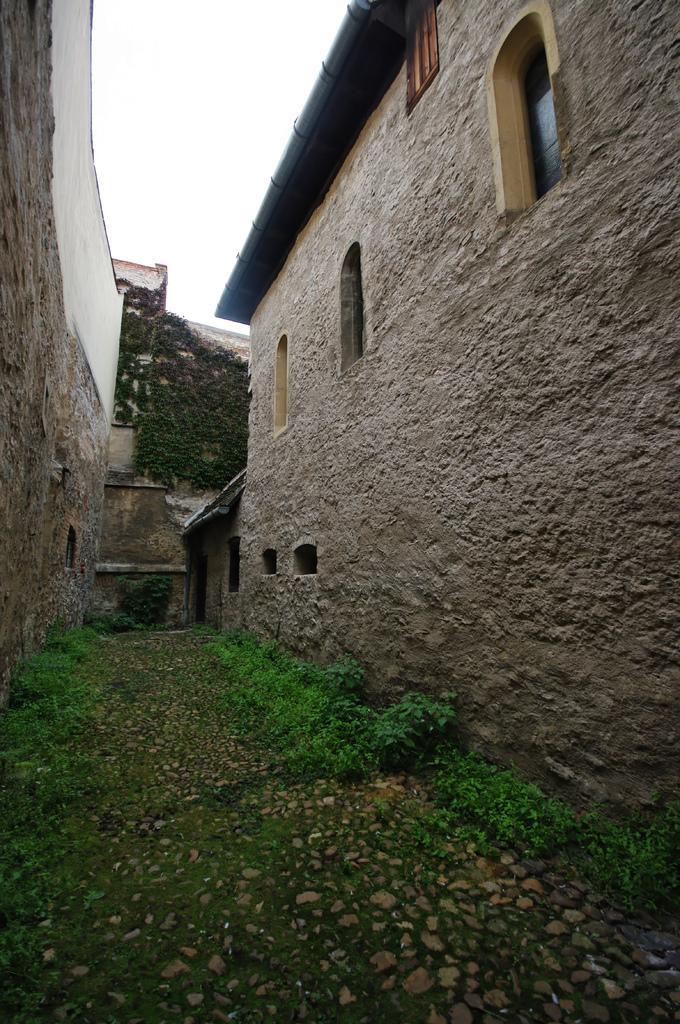In one or two sentences, can you explain what this image depicts? In the image we can see buildings made up of stones and these are the windows. We can even see there are trees, grass, stones and white sky. 